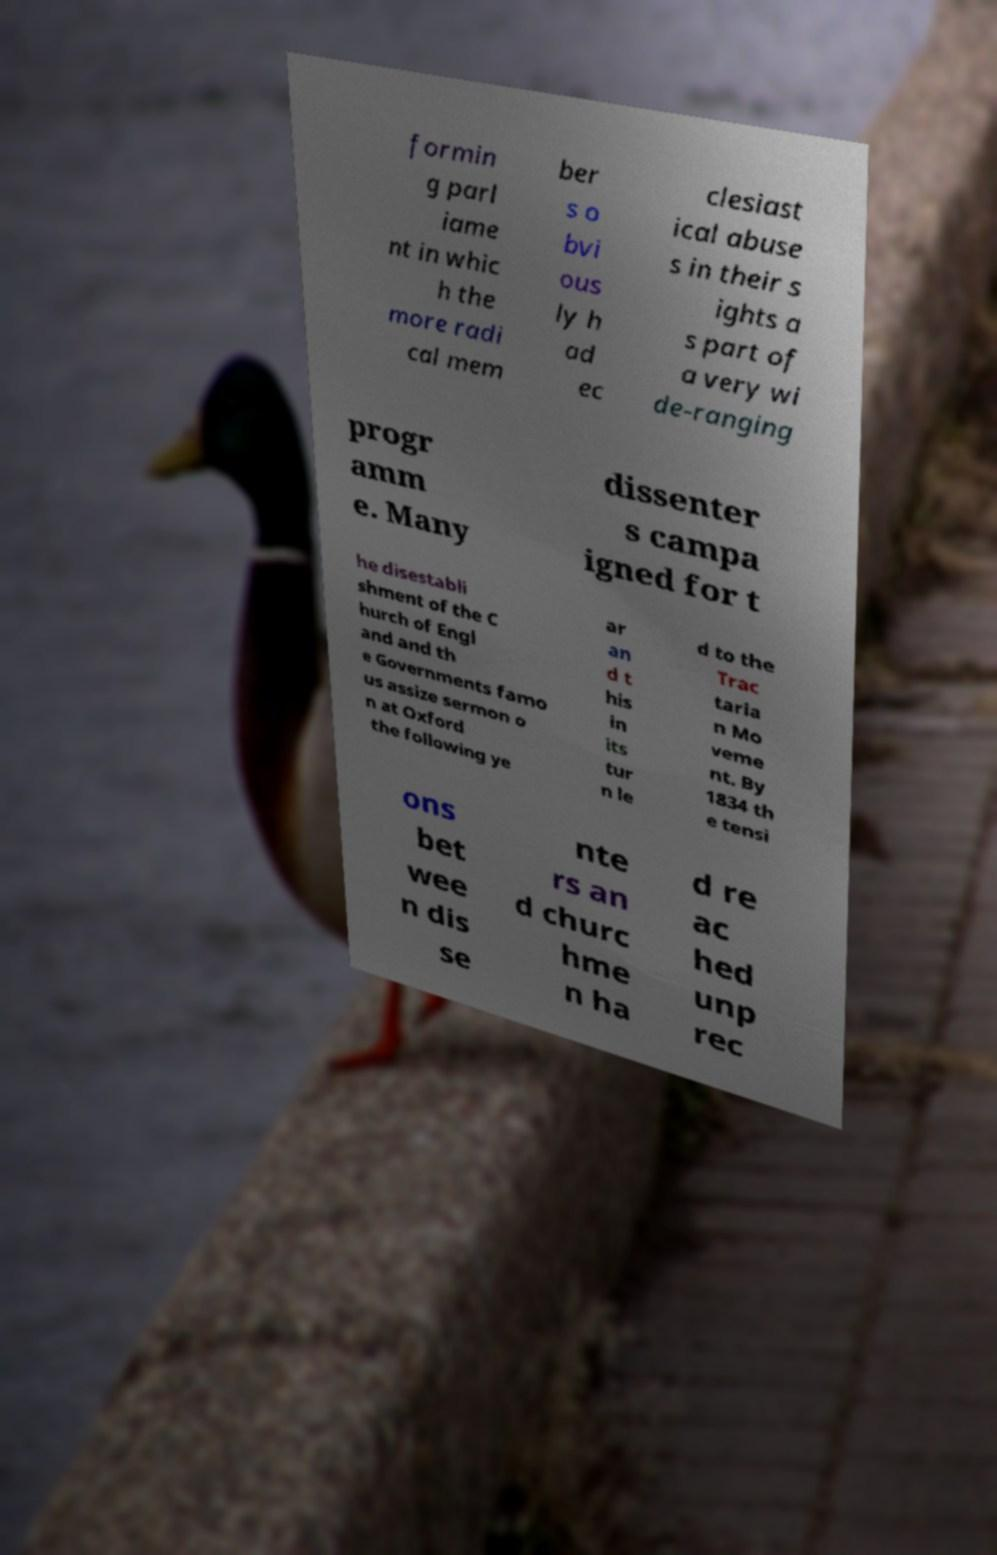Please read and relay the text visible in this image. What does it say? formin g parl iame nt in whic h the more radi cal mem ber s o bvi ous ly h ad ec clesiast ical abuse s in their s ights a s part of a very wi de-ranging progr amm e. Many dissenter s campa igned for t he disestabli shment of the C hurch of Engl and and th e Governments famo us assize sermon o n at Oxford the following ye ar an d t his in its tur n le d to the Trac taria n Mo veme nt. By 1834 th e tensi ons bet wee n dis se nte rs an d churc hme n ha d re ac hed unp rec 